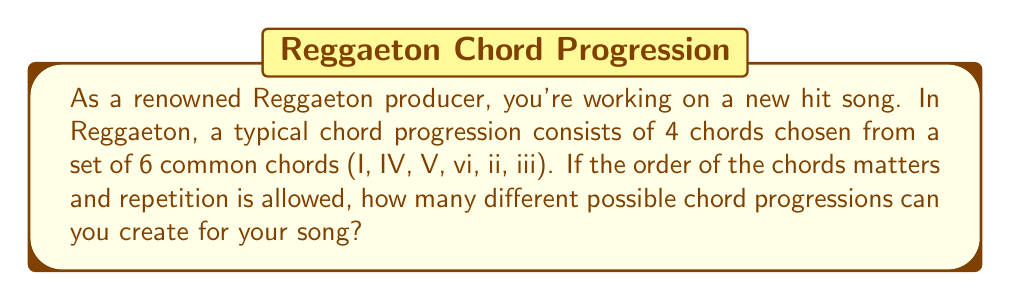Provide a solution to this math problem. Let's approach this step-by-step:

1) We are selecting 4 chords for our progression.

2) We have 6 choices for each position in the progression.

3) The order matters (e.g., I-IV-V-vi is different from IV-I-V-vi).

4) We can repeat chords (e.g., I-IV-I-V is allowed).

This scenario is a perfect example of the multiplication principle in combinatorics. Specifically, it's a case of permutation with repetition.

The formula for this is:

$$ n^r $$

Where:
$n$ = number of options for each choice
$r$ = number of choices to be made

In our case:
$n = 6$ (six chord options)
$r = 4$ (four chords in the progression)

Therefore, the number of possible chord progressions is:

$$ 6^4 = 6 \times 6 \times 6 \times 6 = 1296 $$

This means you have 1296 different possible chord progressions to choose from for your Reggaeton hit!
Answer: 1296 possible chord progressions 